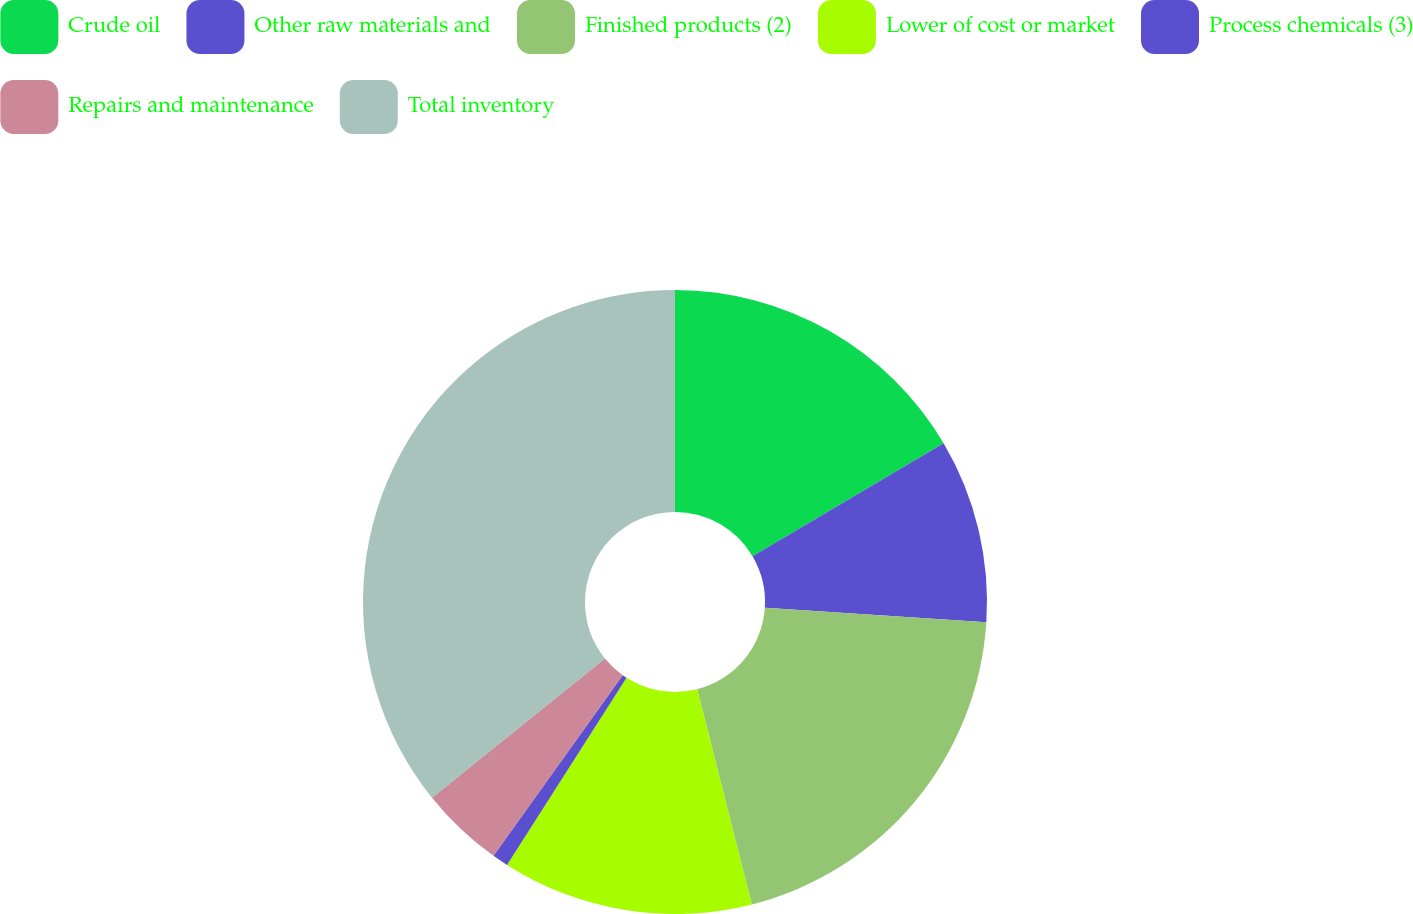Convert chart to OTSL. <chart><loc_0><loc_0><loc_500><loc_500><pie_chart><fcel>Crude oil<fcel>Other raw materials and<fcel>Finished products (2)<fcel>Lower of cost or market<fcel>Process chemicals (3)<fcel>Repairs and maintenance<fcel>Total inventory<nl><fcel>16.51%<fcel>9.52%<fcel>20.01%<fcel>13.01%<fcel>0.83%<fcel>4.33%<fcel>35.79%<nl></chart> 